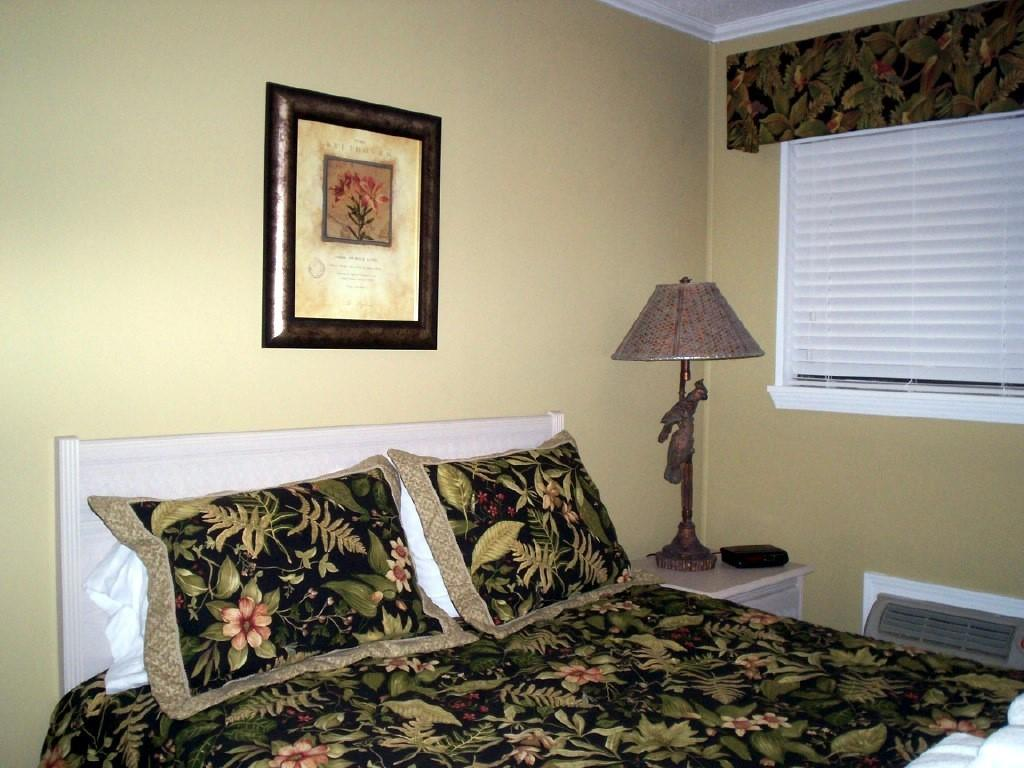What piece of furniture is present in the room for sleeping? There is a bed in the room. How many pillows are on the bed? There are two pillows on the bed. What is hanging on the wall behind the bed? There is a frame on the wall behind the bed. What piece of furniture is present in the room for studying or working? There is a desk in the room. What is used for providing light on the desk? There is a lamp on the desk. Can you see any water flowing in the room? There is no water flowing in the room; the image only shows a bed, pillows, a frame, a desk, and a lamp. 